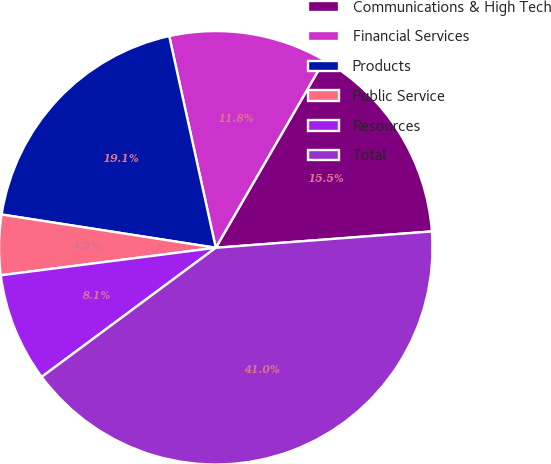Convert chart. <chart><loc_0><loc_0><loc_500><loc_500><pie_chart><fcel>Communications & High Tech<fcel>Financial Services<fcel>Products<fcel>Public Service<fcel>Resources<fcel>Total<nl><fcel>15.45%<fcel>11.79%<fcel>19.1%<fcel>4.48%<fcel>8.13%<fcel>41.04%<nl></chart> 